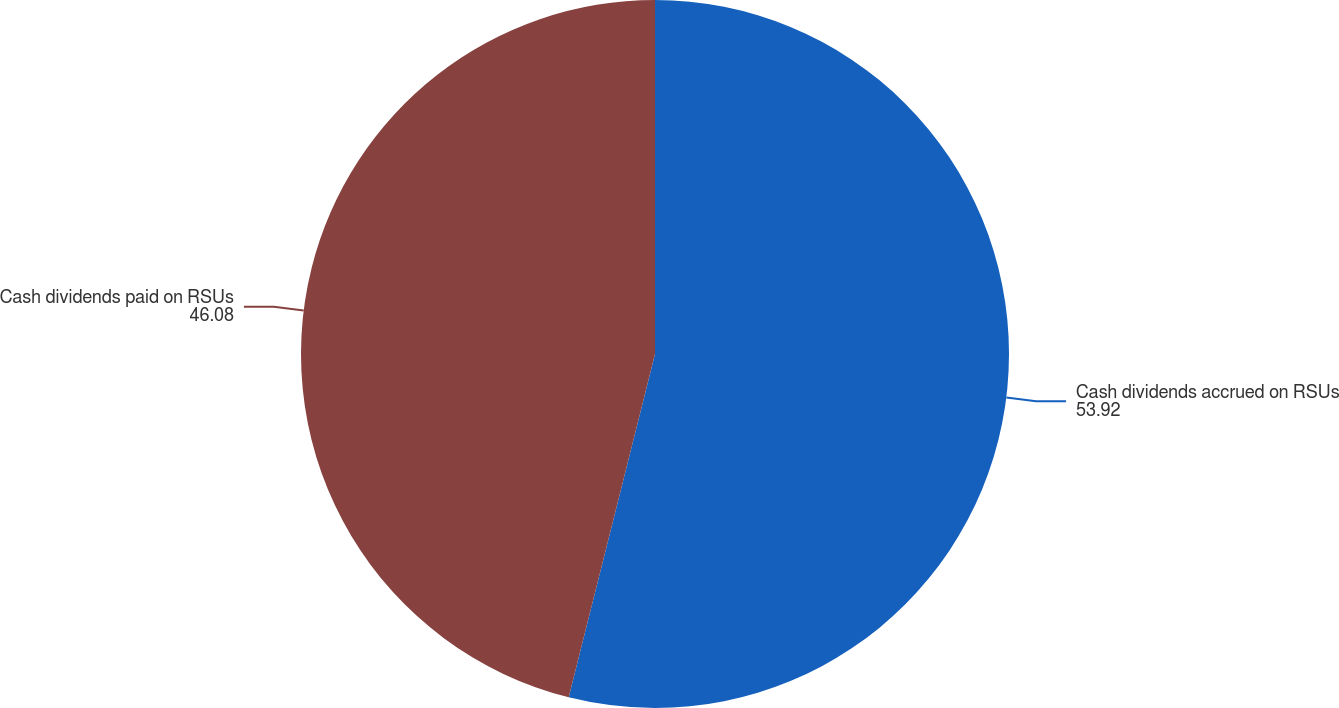Convert chart to OTSL. <chart><loc_0><loc_0><loc_500><loc_500><pie_chart><fcel>Cash dividends accrued on RSUs<fcel>Cash dividends paid on RSUs<nl><fcel>53.92%<fcel>46.08%<nl></chart> 